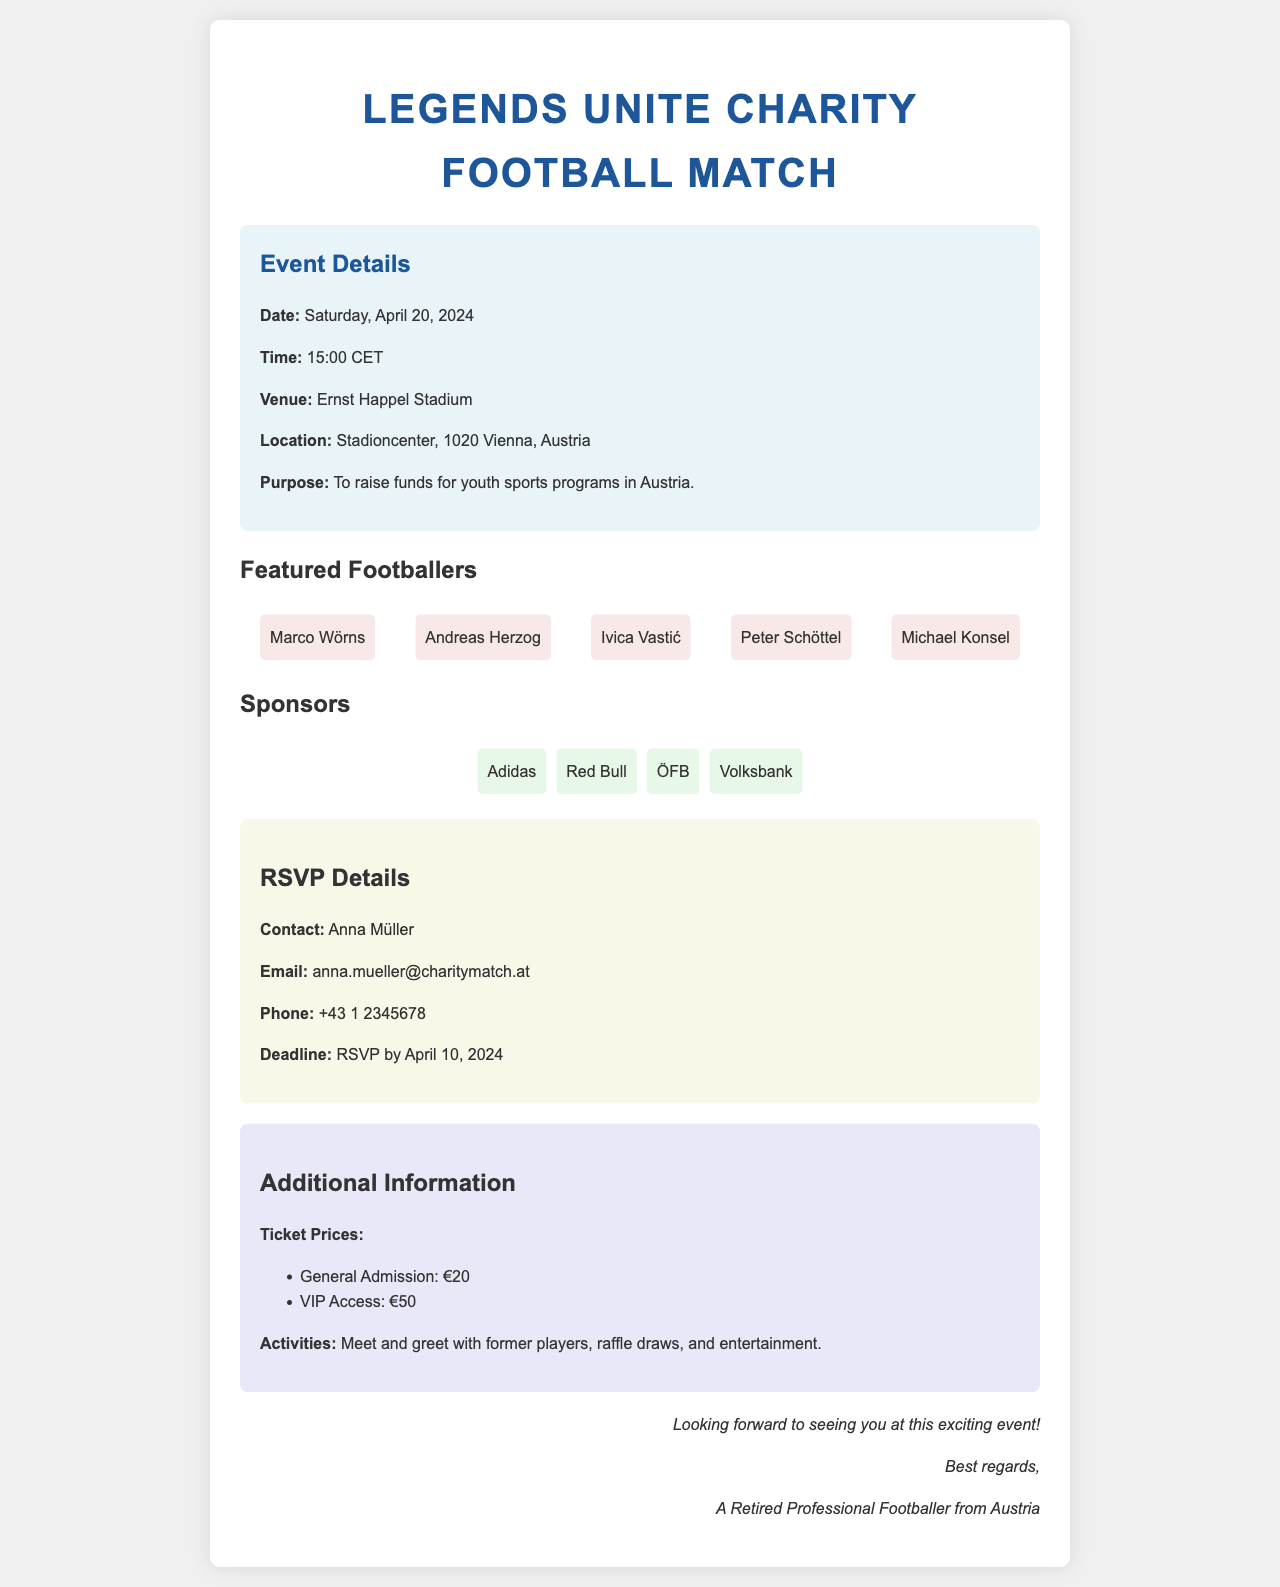What is the date of the event? The date of the event is specified in the document, which indicates "Saturday, April 20, 2024."
Answer: April 20, 2024 What is the venue of the charity match? The venue is mentioned under event details as "Ernst Happel Stadium."
Answer: Ernst Happel Stadium Who is the contact person for RSVPs? The contact person for RSVPs is stated in the RSVP details section as "Anna Müller."
Answer: Anna Müller What is the deadline for RSVPs? The deadline for RSVPs is provided in the document, which is "April 10, 2024."
Answer: April 10, 2024 How much is the General Admission ticket? The ticket prices are listed, with General Admission priced at "€20."
Answer: €20 What activities will be at the event? The document mentions activities such as "Meet and greet with former players, raffle draws, and entertainment."
Answer: Meet and greet with former players, raffle draws, and entertainment Which player is featured first? The first player mentioned in the featured players section is "Marco Wörns."
Answer: Marco Wörns How many sponsors are listed? The sponsors section lists several companies, totaling "four sponsors."
Answer: Four sponsors What does the event aim to raise funds for? The purpose of the event is described as raising funds for "youth sports programs in Austria."
Answer: Youth sports programs in Austria 